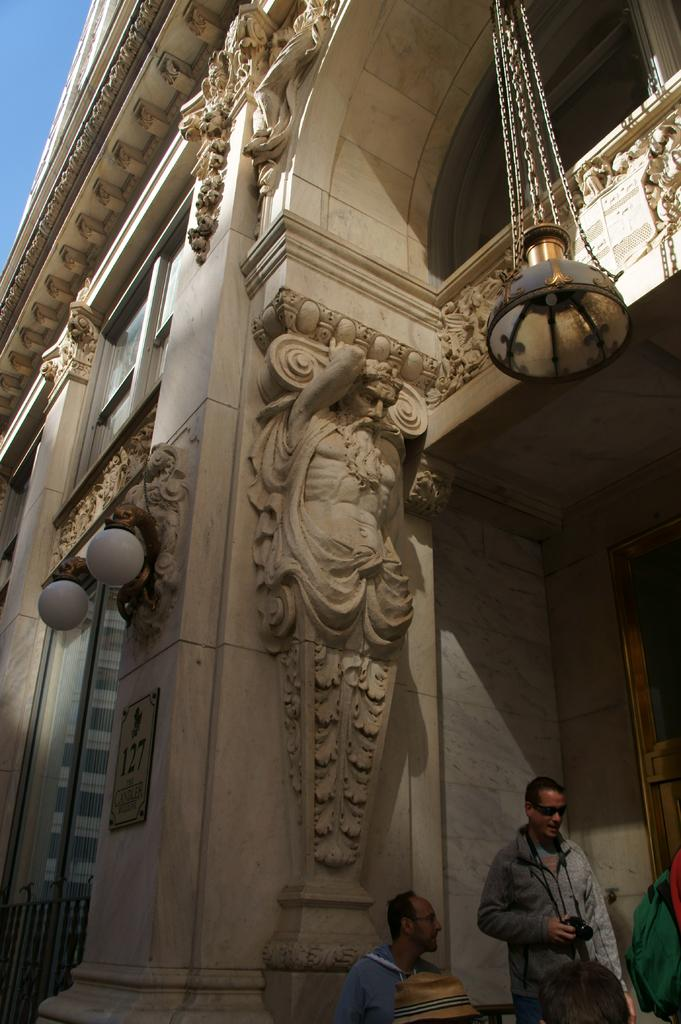What is the main structure in the image? There is a building in the center of the image. Can you describe any specific features of the building? There is a light hanging from the wall. Who or what can be seen at the bottom of the image? There are persons at the bottom of the image. What is visible in the background of the image? There is a wall in the background of the image. What type of education is being provided in the image? There is no indication of education being provided in the image; it primarily features a building with a light and persons at the bottom. Can you tell me the name of the organization that the father is representing in the image? There is no father or organization present in the image. 